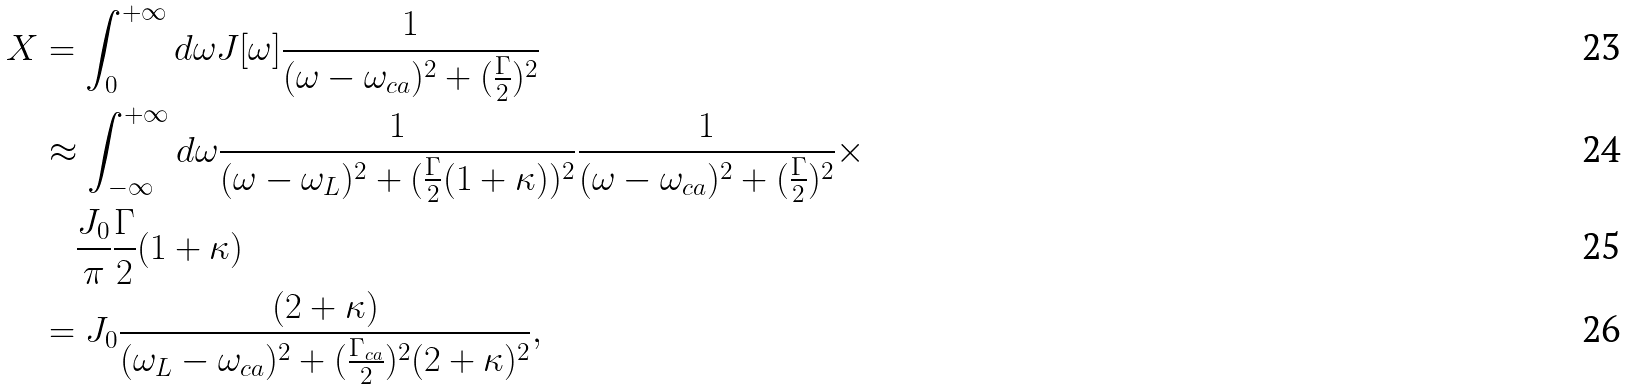Convert formula to latex. <formula><loc_0><loc_0><loc_500><loc_500>X & = \int _ { 0 } ^ { + \infty } d \omega J [ \omega ] \frac { 1 } { ( \omega - \omega _ { c a } ) ^ { 2 } + ( \frac { \Gamma } { 2 } ) ^ { 2 } } \\ & \approx \int _ { - \infty } ^ { + \infty } d \omega \frac { 1 } { ( \omega - \omega _ { L } ) ^ { 2 } + ( \frac { \Gamma } { 2 } ( 1 + \kappa ) ) ^ { 2 } } \frac { 1 } { ( \omega - \omega _ { c a } ) ^ { 2 } + ( \frac { \Gamma } { 2 } ) ^ { 2 } } \times \\ & \quad \frac { J _ { 0 } } { \pi } \frac { \Gamma } { 2 } ( 1 + \kappa ) \\ & = J _ { 0 } \frac { ( 2 + \kappa ) } { ( \omega _ { L } - \omega _ { c a } ) ^ { 2 } + ( \frac { \Gamma _ { c a } } { 2 } ) ^ { 2 } ( 2 + \kappa ) ^ { 2 } } ,</formula> 